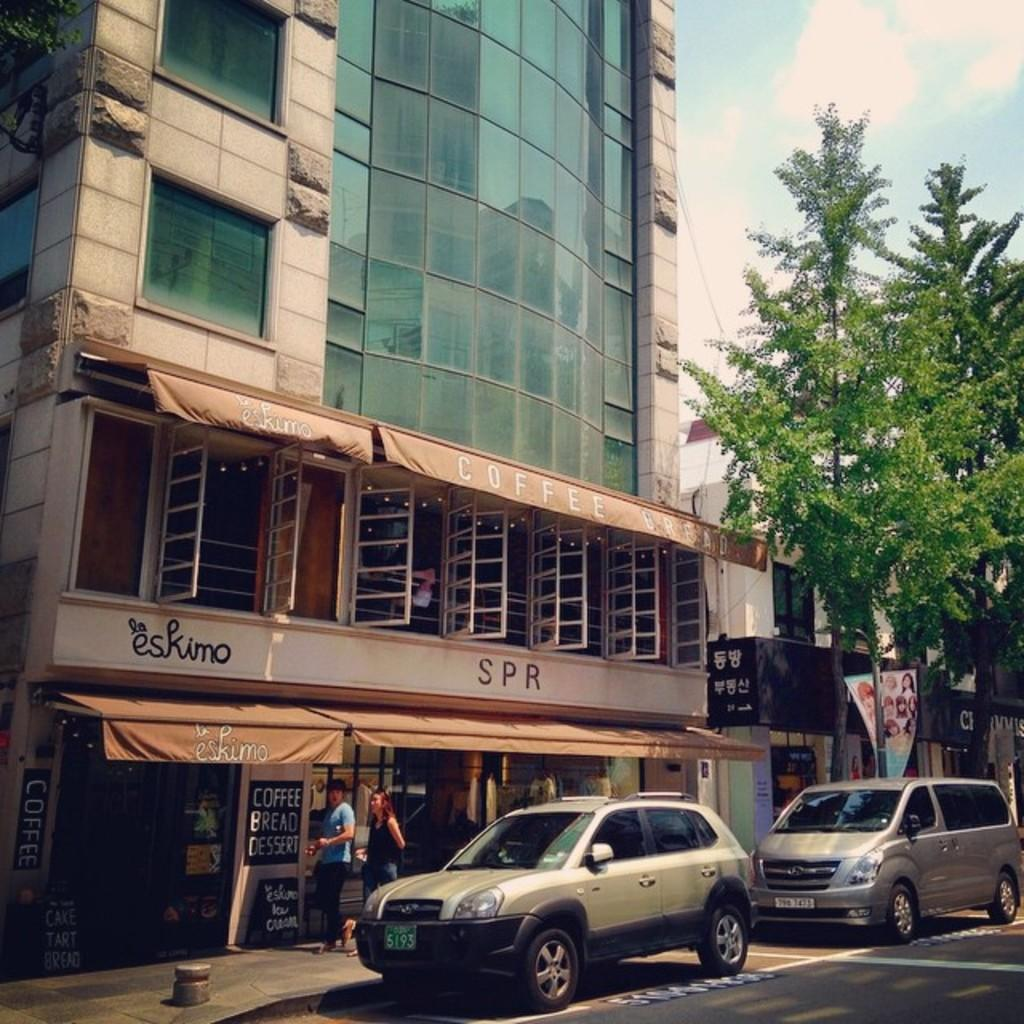What type of structures can be seen in the image? There are buildings in the image. What natural element is present in the image? There is a tree in the image. Who or what else is visible in the image? There are people and vehicles in the image. What type of signage or advertisements are present in the image? There are hoardings or boards in the image. What feature do the buildings have? The buildings have windows. What is the temperature like during the protest in the image? There is no protest present in the image, and therefore no information about the temperature can be provided. 